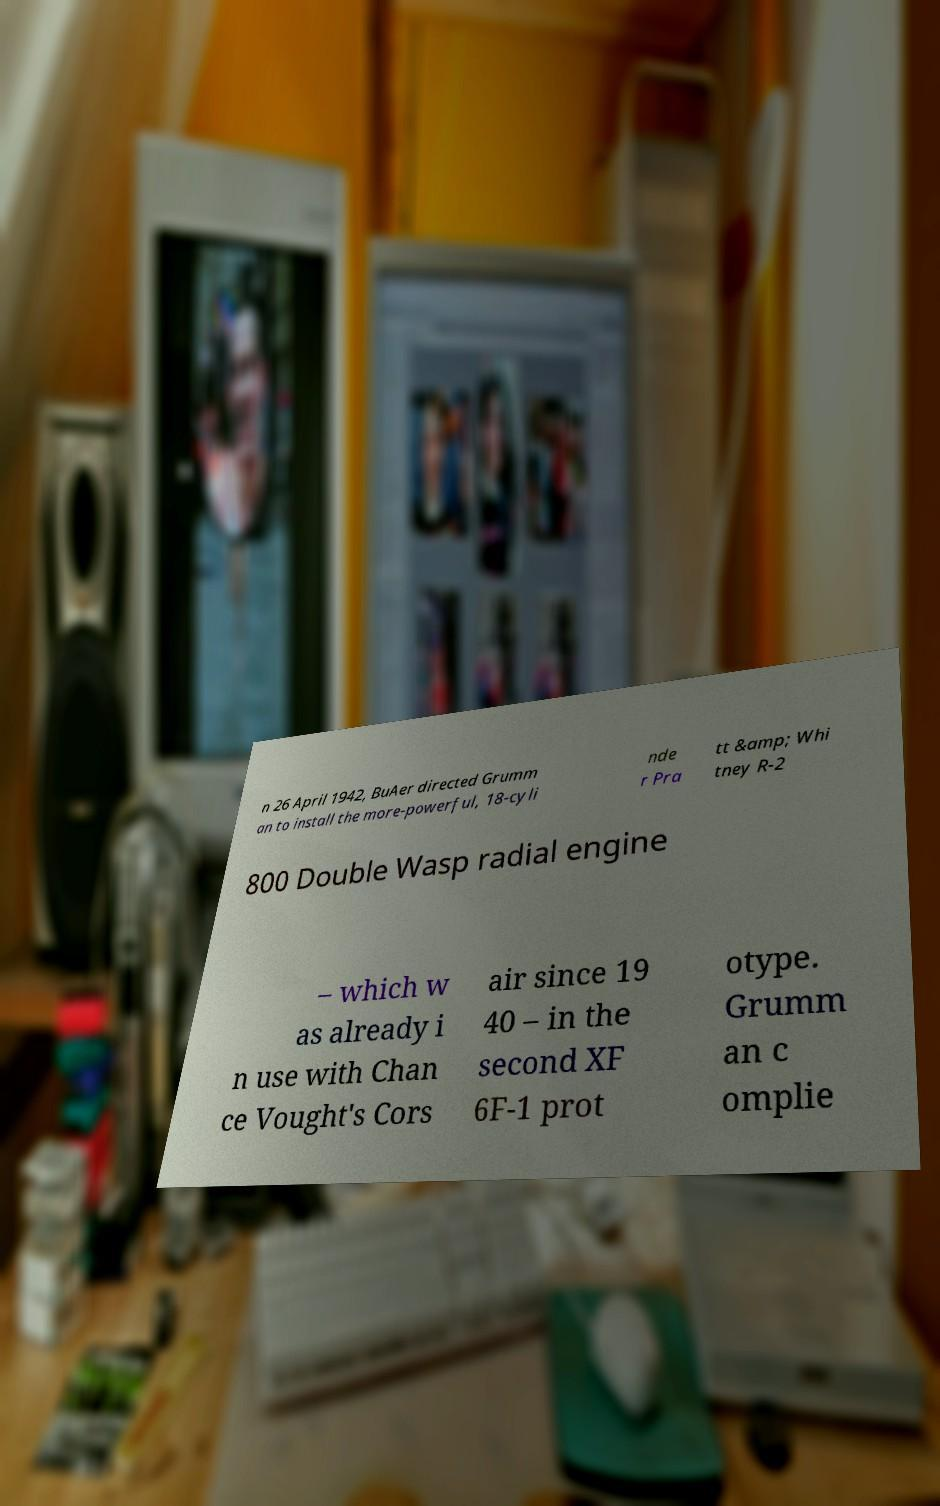Please read and relay the text visible in this image. What does it say? n 26 April 1942, BuAer directed Grumm an to install the more-powerful, 18-cyli nde r Pra tt &amp; Whi tney R-2 800 Double Wasp radial engine – which w as already i n use with Chan ce Vought's Cors air since 19 40 – in the second XF 6F-1 prot otype. Grumm an c omplie 